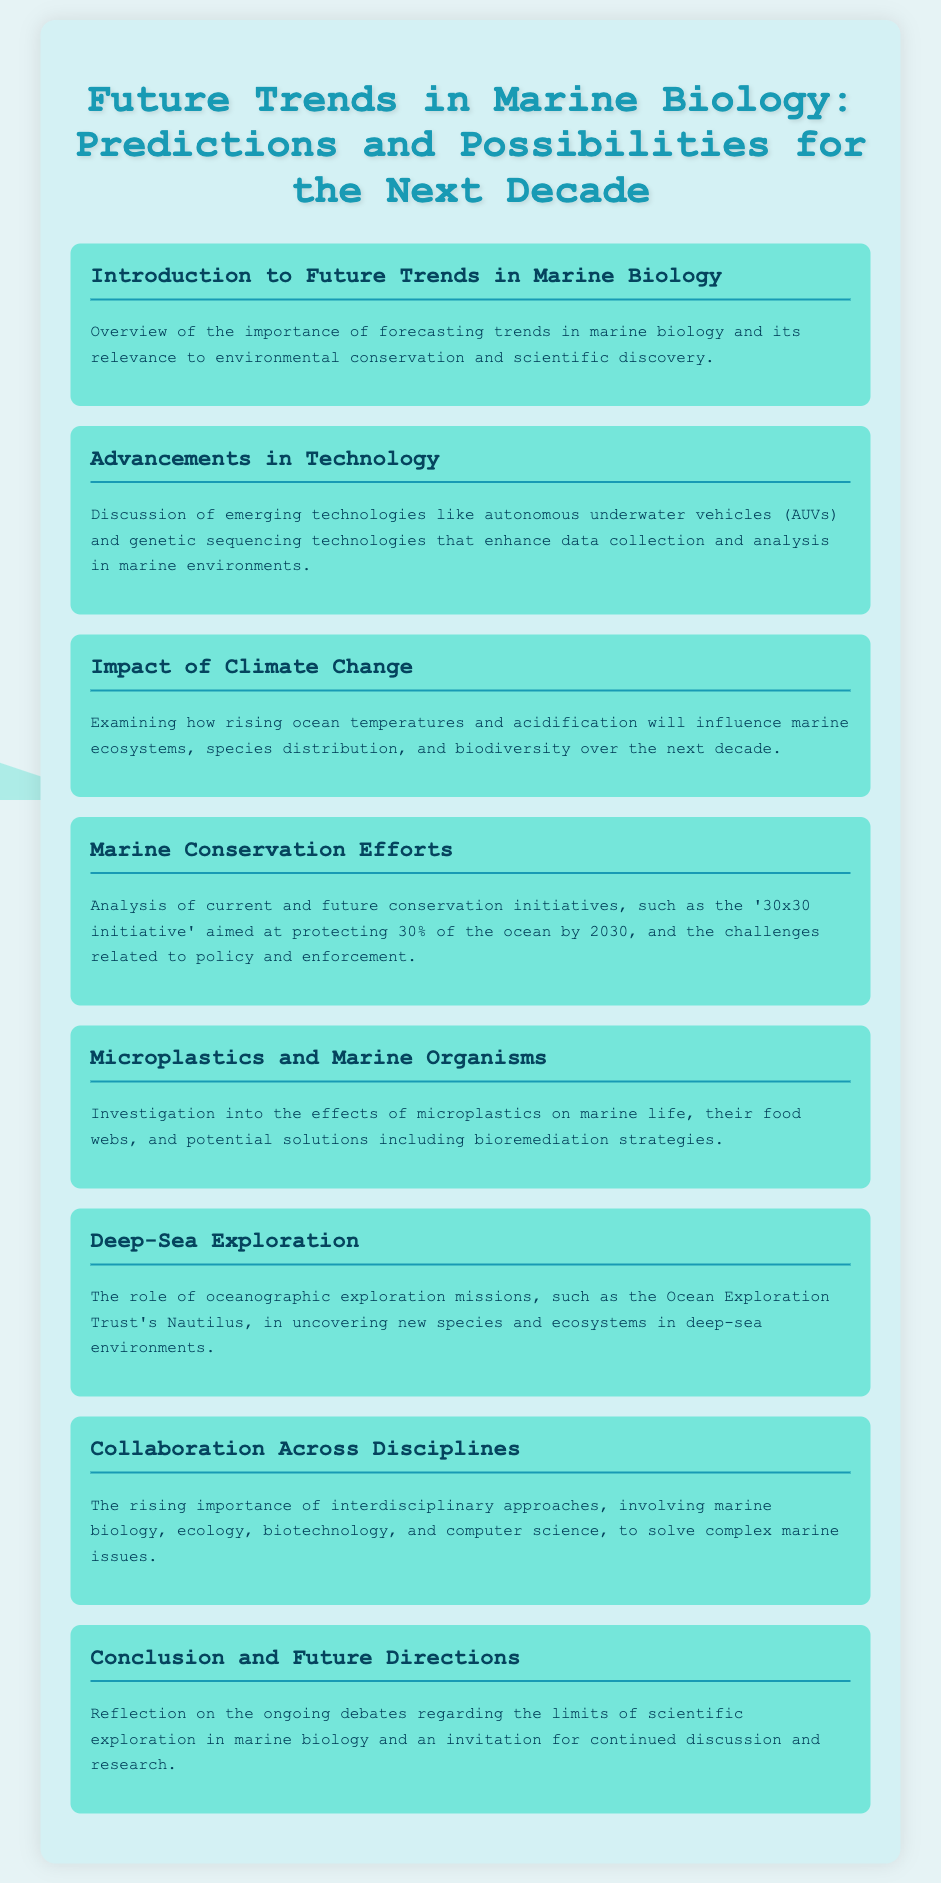what is the title of the document? The title of the document is presented prominently at the top, indicating the focus on future trends in marine biology.
Answer: Future Trends in Marine Biology: Predictions and Possibilities for the Next Decade what is discussed in the section about advancements in technology? The section explores emerging technologies such as autonomous underwater vehicles and genetic sequencing technologies that improve data collection and analysis.
Answer: Emerging technologies like autonomous underwater vehicles and genetic sequencing technologies what initiative is mentioned for marine conservation? The document discusses a significant conservation initiative that aims to protect a specific percentage of the ocean by a target year.
Answer: 30x30 initiative what are two impacts of climate change mentioned? The document highlights how climate change affects marine ecosystems, specifically mentioning ocean temperatures and acidification.
Answer: Rising ocean temperatures and acidification which organization is referenced in the deep-sea exploration section? The section on deep-sea exploration cites a specific organization involved in uncovering new species and ecosystems in deep-sea environments.
Answer: Ocean Exploration Trust what is the focus of the section on microplastics? This section examines the consequences of microplastics on marine life and possible solutions to this problem.
Answer: Effects of microplastics on marine life what concept is emphasized for future marine biology research? The document stresses the importance of interdisciplinary approaches in addressing complex marine issues.
Answer: Collaboration Across Disciplines how many percent of the ocean does the '30x30 initiative' aim to protect by 2030? The initiative's goal is to protect a certain percentage of the ocean by the year 2030, as specified in the conservation efforts section.
Answer: 30% 